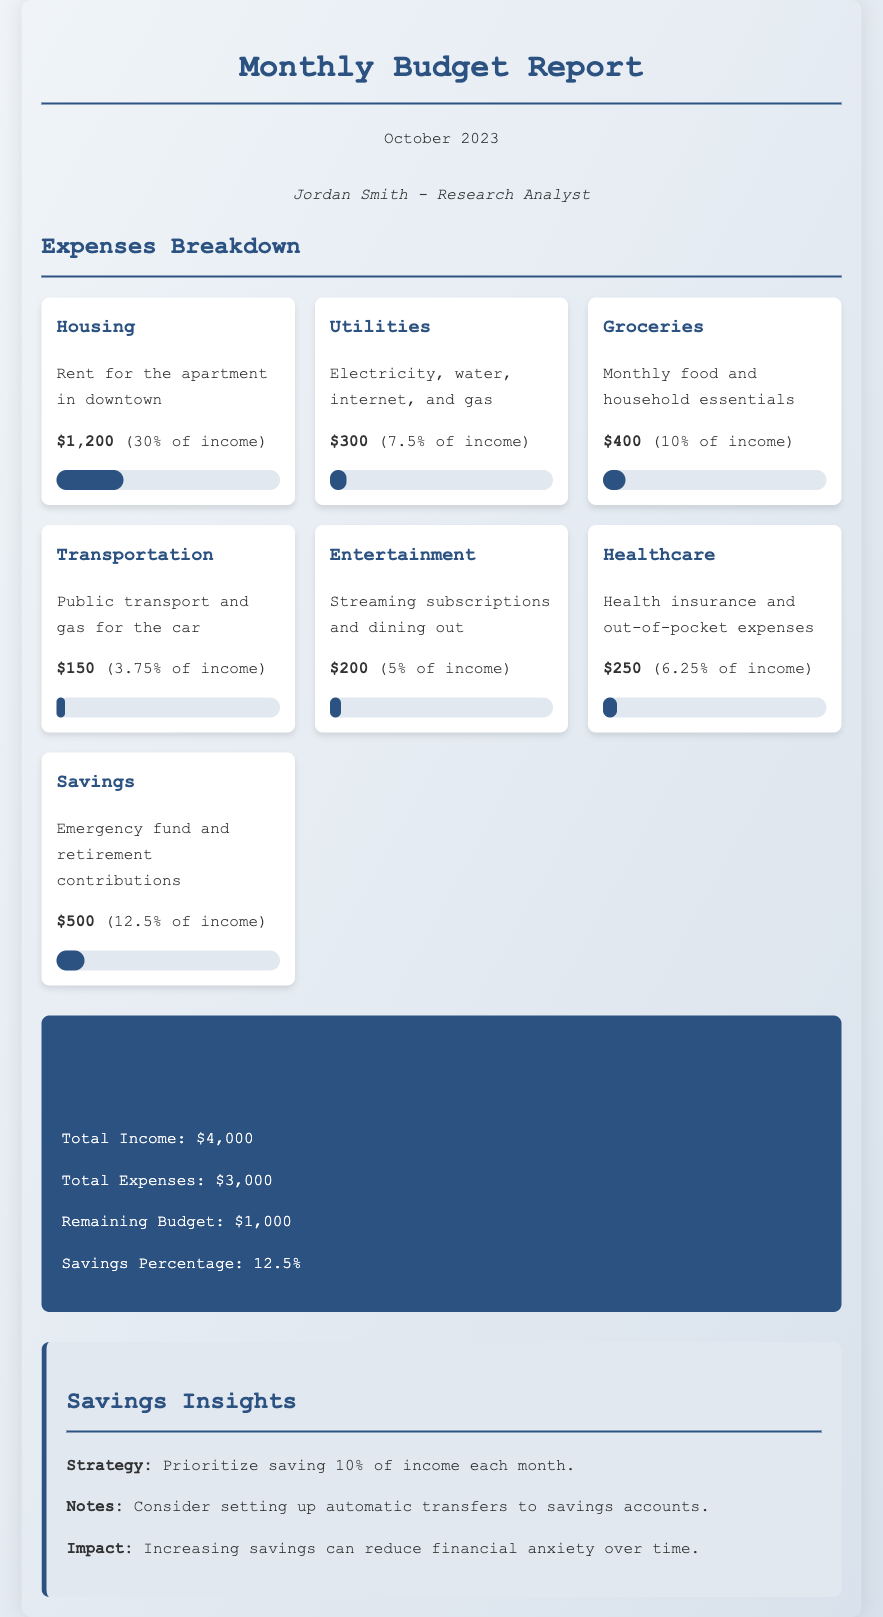what is the total income? The total income is stated in the totals section of the document, which is $4,000.
Answer: $4,000 how much is allocated for groceries? The expenses breakdown lists groceries with an amount of $400.
Answer: $400 what percentage of income goes to housing? The document specifies that housing costs 30% of income.
Answer: 30% what is the remaining budget after expenses? The remaining budget is calculated in the totals section as $1,000 after deducting total expenses from total income.
Answer: $1,000 how much is budgeted for entertainment? The entertainment category shows a budget of $200.
Answer: $200 what is the total expenses amount? The document includes a total expenses figure of $3,000.
Answer: $3,000 which category has the highest expense? The housing category has the highest expense at $1,200.
Answer: Housing what is the suggested savings strategy? The insights suggest prioritizing saving 10% of income each month.
Answer: Prioritize saving 10% how does increased savings impact financial anxiety? The document notes that increasing savings can reduce financial anxiety over time.
Answer: Reduce financial anxiety 